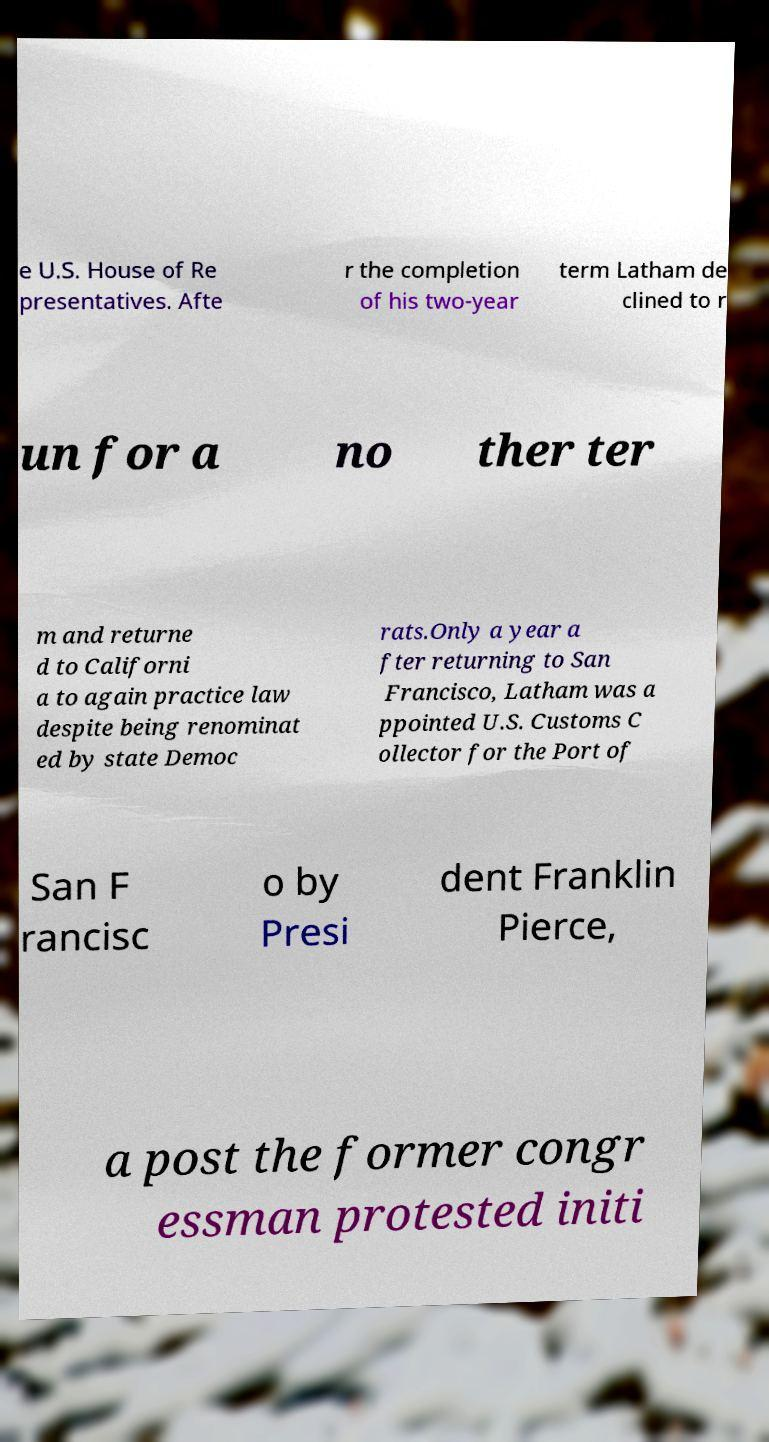I need the written content from this picture converted into text. Can you do that? e U.S. House of Re presentatives. Afte r the completion of his two-year term Latham de clined to r un for a no ther ter m and returne d to Californi a to again practice law despite being renominat ed by state Democ rats.Only a year a fter returning to San Francisco, Latham was a ppointed U.S. Customs C ollector for the Port of San F rancisc o by Presi dent Franklin Pierce, a post the former congr essman protested initi 